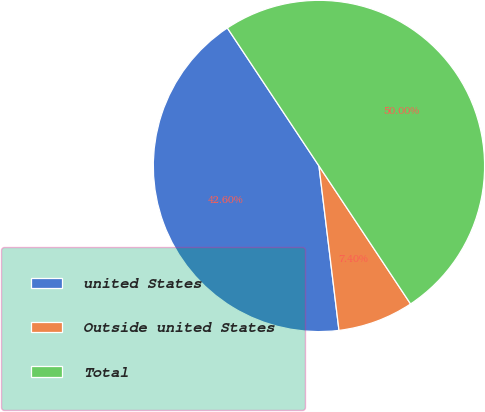Convert chart to OTSL. <chart><loc_0><loc_0><loc_500><loc_500><pie_chart><fcel>united States<fcel>Outside united States<fcel>Total<nl><fcel>42.6%<fcel>7.4%<fcel>50.0%<nl></chart> 